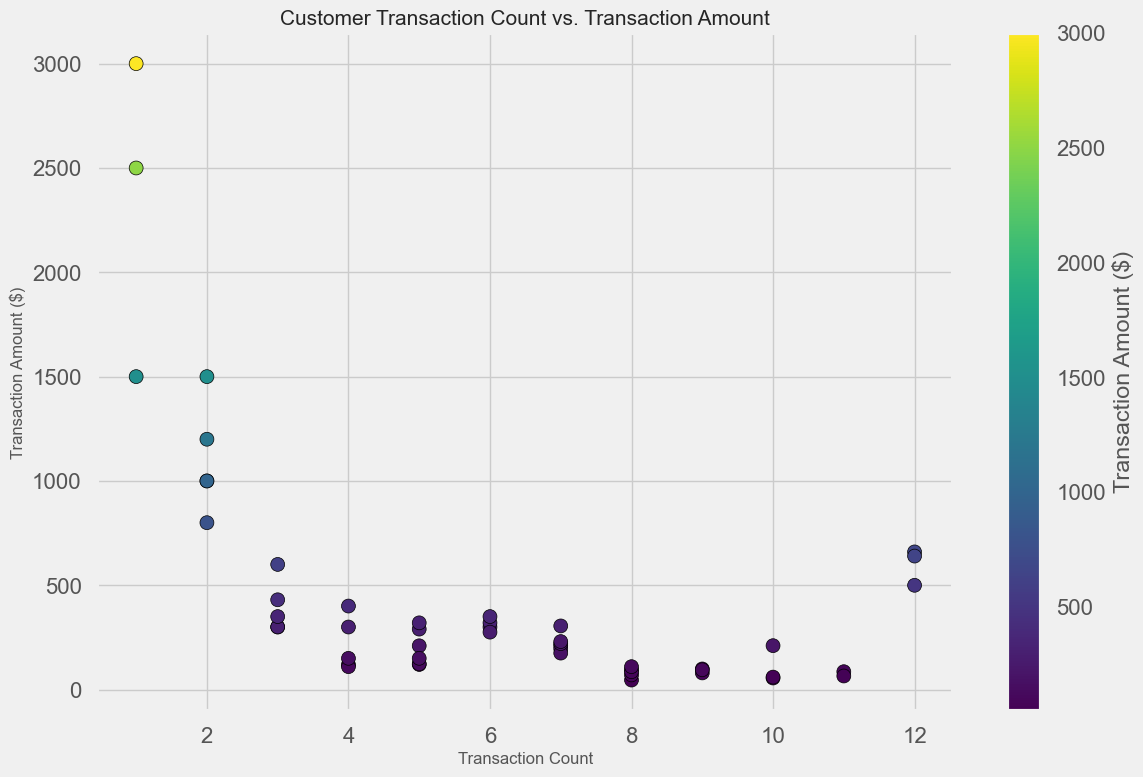What is the transaction amount for the customer with the highest transaction count? Look for the highest point on the x-axis (transaction count), which appears to be 12. The corresponding transaction amount (y-axis) for that count is around 660.00.
Answer: 660.00 Which customer had the highest transaction amount? Identify the point that is highest on the y-axis. The highest transaction amount is around 3000.00, which corresponds to a customer with a low transaction count.
Answer: 3000.00 Do customers with higher transaction counts typically have higher transaction amounts? Observe the scatter plot to see the distribution of points. Points with higher transaction counts (right side) do not consistently have higher transaction amounts; there are high amounts scattered across varying counts.
Answer: No What is the average transaction amount for customers with less than 3 transactions? Identify points with transaction counts less than 3 (leftmost points on the x-axis), which are (2, 1000), (2, 800), (2, 1200), (2, 1000), and (1, 2500), (1, 3000), (1, 1500). Average their transaction amounts: (1000 + 800 + 1200 + 1000 + 2500 + 3000 + 1500) / 7 = 1571.43.
Answer: 1571.43 Are there any customers with exactly 5 transactions and a transaction amount between 100 and 200? Look for points where the x-axis value is 5 and the y-axis value lies between 100 and 200. These points are around (5, 120.50), (5, 123.45), (5, 150.00), and (5, 150.00).
Answer: Yes Which three customers have the highest transaction amounts, regardless of transaction count? Identify the three highest points on the y-axis. The highest transaction amounts are around 3000.00, 2500.00, and 1500.00.
Answer: 3000.00, 2500.00, 1500.00 Is there a correlation between transaction count and transaction amount? Observe the overall pattern formed by the scatter plot points. The points do not show a clear trend indicating correlation; they are quite scattered.
Answer: No clear correlation Which customer with a transaction count of 6 has the highest transaction amount? Look at points where the x-axis is 6, then find the highest point among them on the y-axis. The highest point is around 350.00.
Answer: 350.00 What is the range of transaction amounts for customers with 10 transactions? Identify points where the x-axis value is 10. The transaction amounts for these points are around 55.60, 60.00, and 210.60. The range is the difference between the highest and lowest amounts: 210.60 - 55.60 = 155.00.
Answer: 155.00 